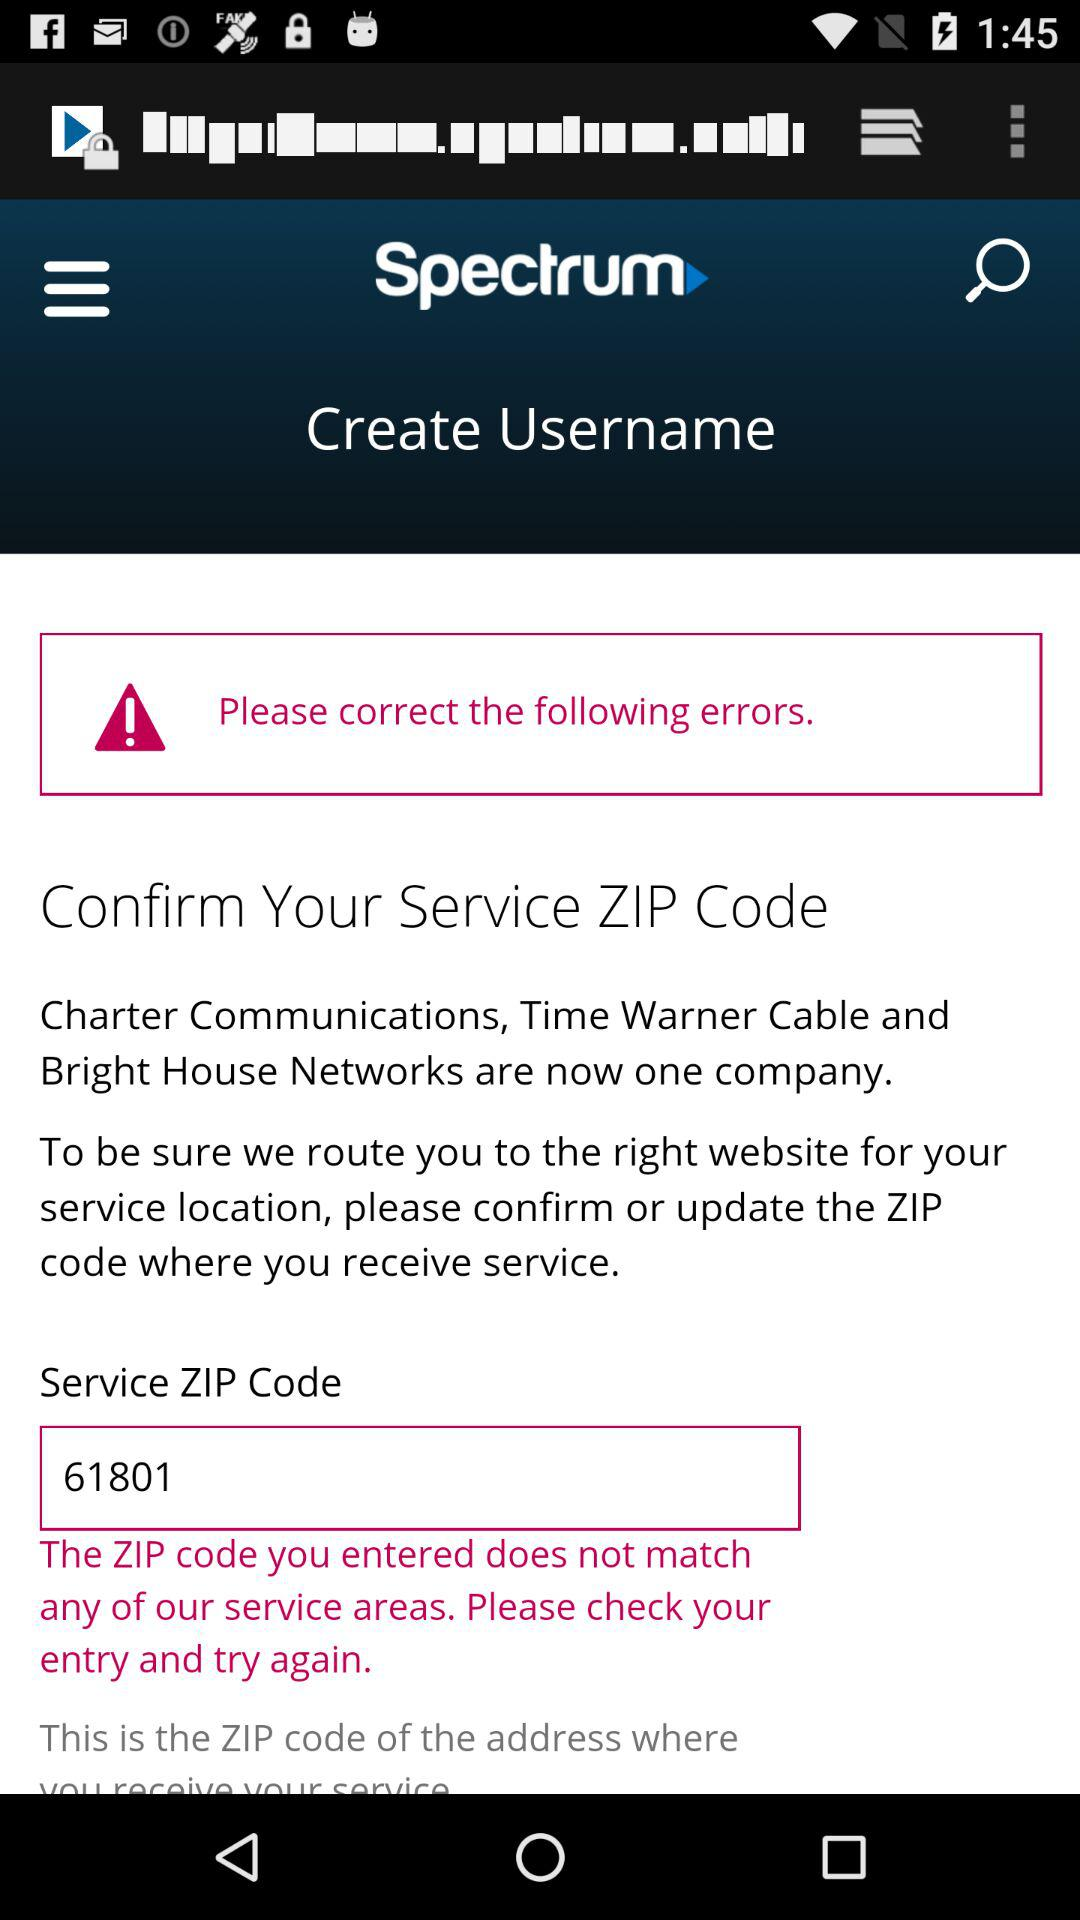What is the service ZIP code? The service ZIP code is 61801. 